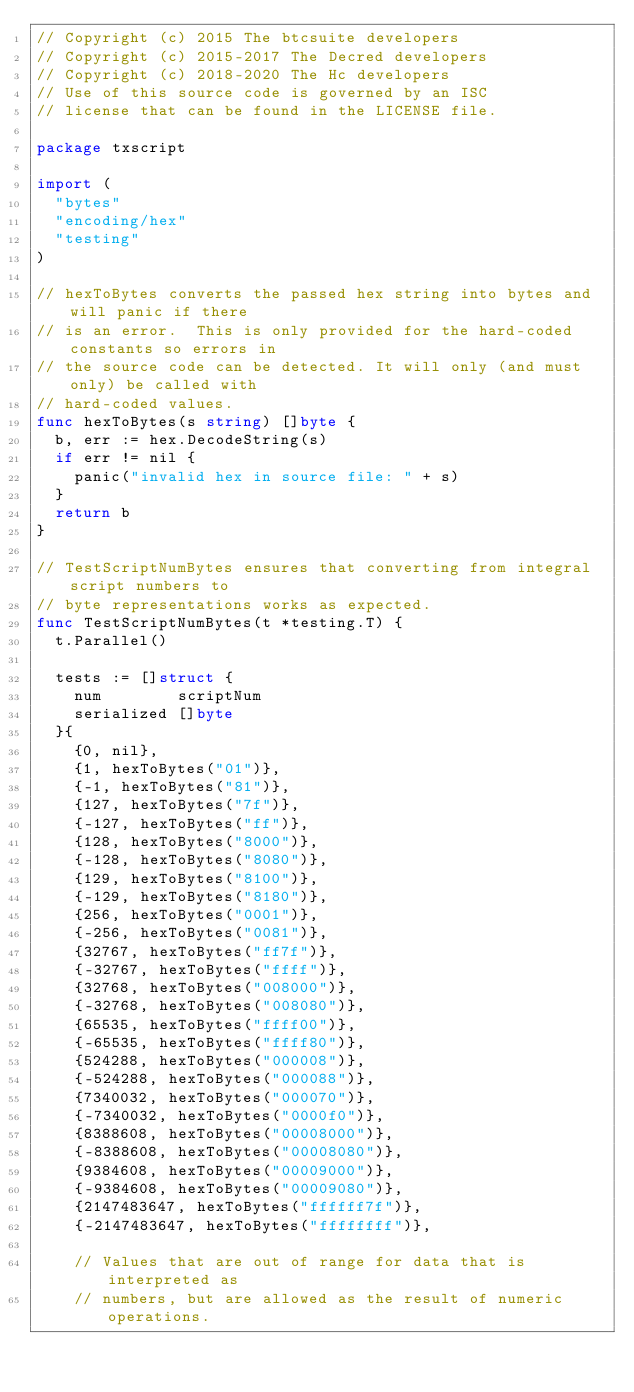<code> <loc_0><loc_0><loc_500><loc_500><_Go_>// Copyright (c) 2015 The btcsuite developers
// Copyright (c) 2015-2017 The Decred developers 
// Copyright (c) 2018-2020 The Hc developers
// Use of this source code is governed by an ISC
// license that can be found in the LICENSE file.

package txscript

import (
	"bytes"
	"encoding/hex"
	"testing"
)

// hexToBytes converts the passed hex string into bytes and will panic if there
// is an error.  This is only provided for the hard-coded constants so errors in
// the source code can be detected. It will only (and must only) be called with
// hard-coded values.
func hexToBytes(s string) []byte {
	b, err := hex.DecodeString(s)
	if err != nil {
		panic("invalid hex in source file: " + s)
	}
	return b
}

// TestScriptNumBytes ensures that converting from integral script numbers to
// byte representations works as expected.
func TestScriptNumBytes(t *testing.T) {
	t.Parallel()

	tests := []struct {
		num        scriptNum
		serialized []byte
	}{
		{0, nil},
		{1, hexToBytes("01")},
		{-1, hexToBytes("81")},
		{127, hexToBytes("7f")},
		{-127, hexToBytes("ff")},
		{128, hexToBytes("8000")},
		{-128, hexToBytes("8080")},
		{129, hexToBytes("8100")},
		{-129, hexToBytes("8180")},
		{256, hexToBytes("0001")},
		{-256, hexToBytes("0081")},
		{32767, hexToBytes("ff7f")},
		{-32767, hexToBytes("ffff")},
		{32768, hexToBytes("008000")},
		{-32768, hexToBytes("008080")},
		{65535, hexToBytes("ffff00")},
		{-65535, hexToBytes("ffff80")},
		{524288, hexToBytes("000008")},
		{-524288, hexToBytes("000088")},
		{7340032, hexToBytes("000070")},
		{-7340032, hexToBytes("0000f0")},
		{8388608, hexToBytes("00008000")},
		{-8388608, hexToBytes("00008080")},
		{9384608, hexToBytes("00009000")},
		{-9384608, hexToBytes("00009080")},
		{2147483647, hexToBytes("ffffff7f")},
		{-2147483647, hexToBytes("ffffffff")},

		// Values that are out of range for data that is interpreted as
		// numbers, but are allowed as the result of numeric operations.</code> 